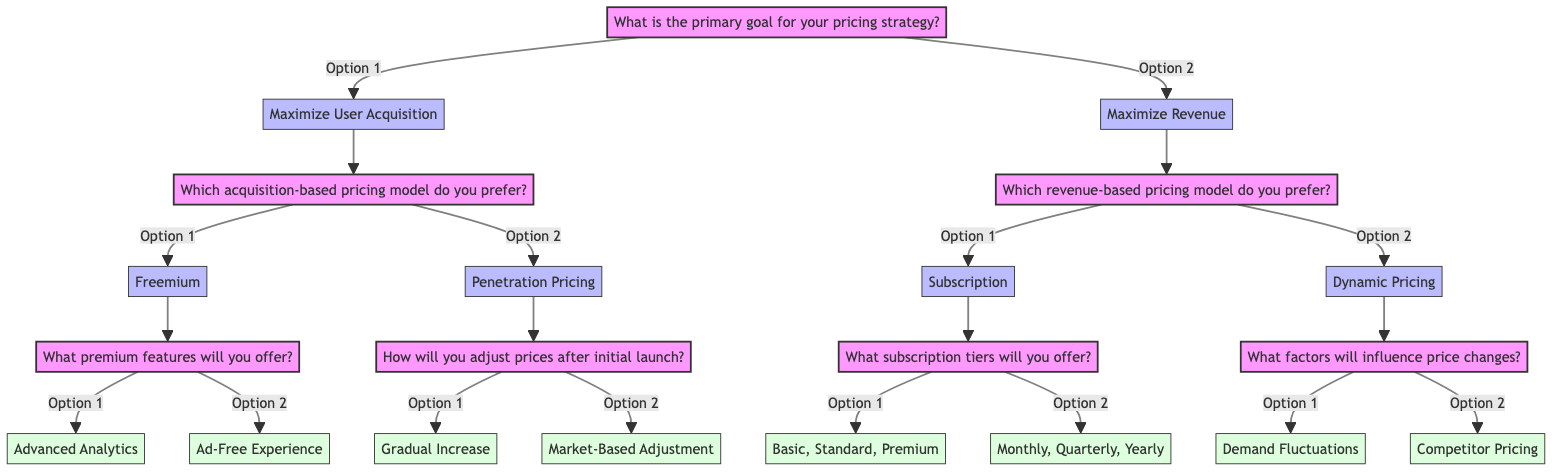What is the primary goal for the pricing strategy? The diagram indicates that the primary goal can be one of two options: "Maximize User Acquisition" or "Maximize Revenue." These are the first-level answers branching directly from the starting question.
Answer: Maximize User Acquisition or Maximize Revenue How many follow-up questions are there after the first node? After the primary goal question, there are two follow-up questions—one for each of the two pricing goals—resulting in a total of two questions.
Answer: 2 What pricing model do you prefer if your goal is to maximize revenue? The diagram shows that if the goal is to maximize revenue, the follow-up question asks for a preferred revenue-based pricing model. The options given are "Subscription" and "Dynamic Pricing."
Answer: Subscription or Dynamic Pricing What premium features will you offer if you prefer a freemium model? The diagram states that if "Freemium" is chosen as the acquisition-based model, a follow-up question will ask for the premium features, which can be either "Advanced Analytics" or "Ad-Free Experience."
Answer: Advanced Analytics or Ad-Free Experience What are the options for how to adjust prices after the initial launch? This is found by tracing the path where "Maximize User Acquisition" leads to "Penetration Pricing." The follow-up asks how to adjust prices, leading to two options: "Gradual Increase" and "Market-Based Adjustment."
Answer: Gradual Increase or Market-Based Adjustment What are the subscription tiers offered under the subscription model? If "Subscription" is selected under the revenue models, the follow-up question asks about the subscription tiers, which can be either "Basic, Standard, Premium" or "Monthly, Quarterly, Yearly."
Answer: Basic, Standard, Premium or Monthly, Quarterly, Yearly What factors will influence price changes under the dynamic pricing model? The dynamic pricing model leads to a question regarding influencing factors. The diagram specifies two options: "Demand Fluctuations" and "Competitor Pricing."
Answer: Demand Fluctuations or Competitor Pricing How many edges connect the second-level nodes to their respective follow-up questions? Each second-level node branches out into two follow-up questions based on the options they present, resulting in a total of four edges corresponding to the four second-level options available.
Answer: 4 